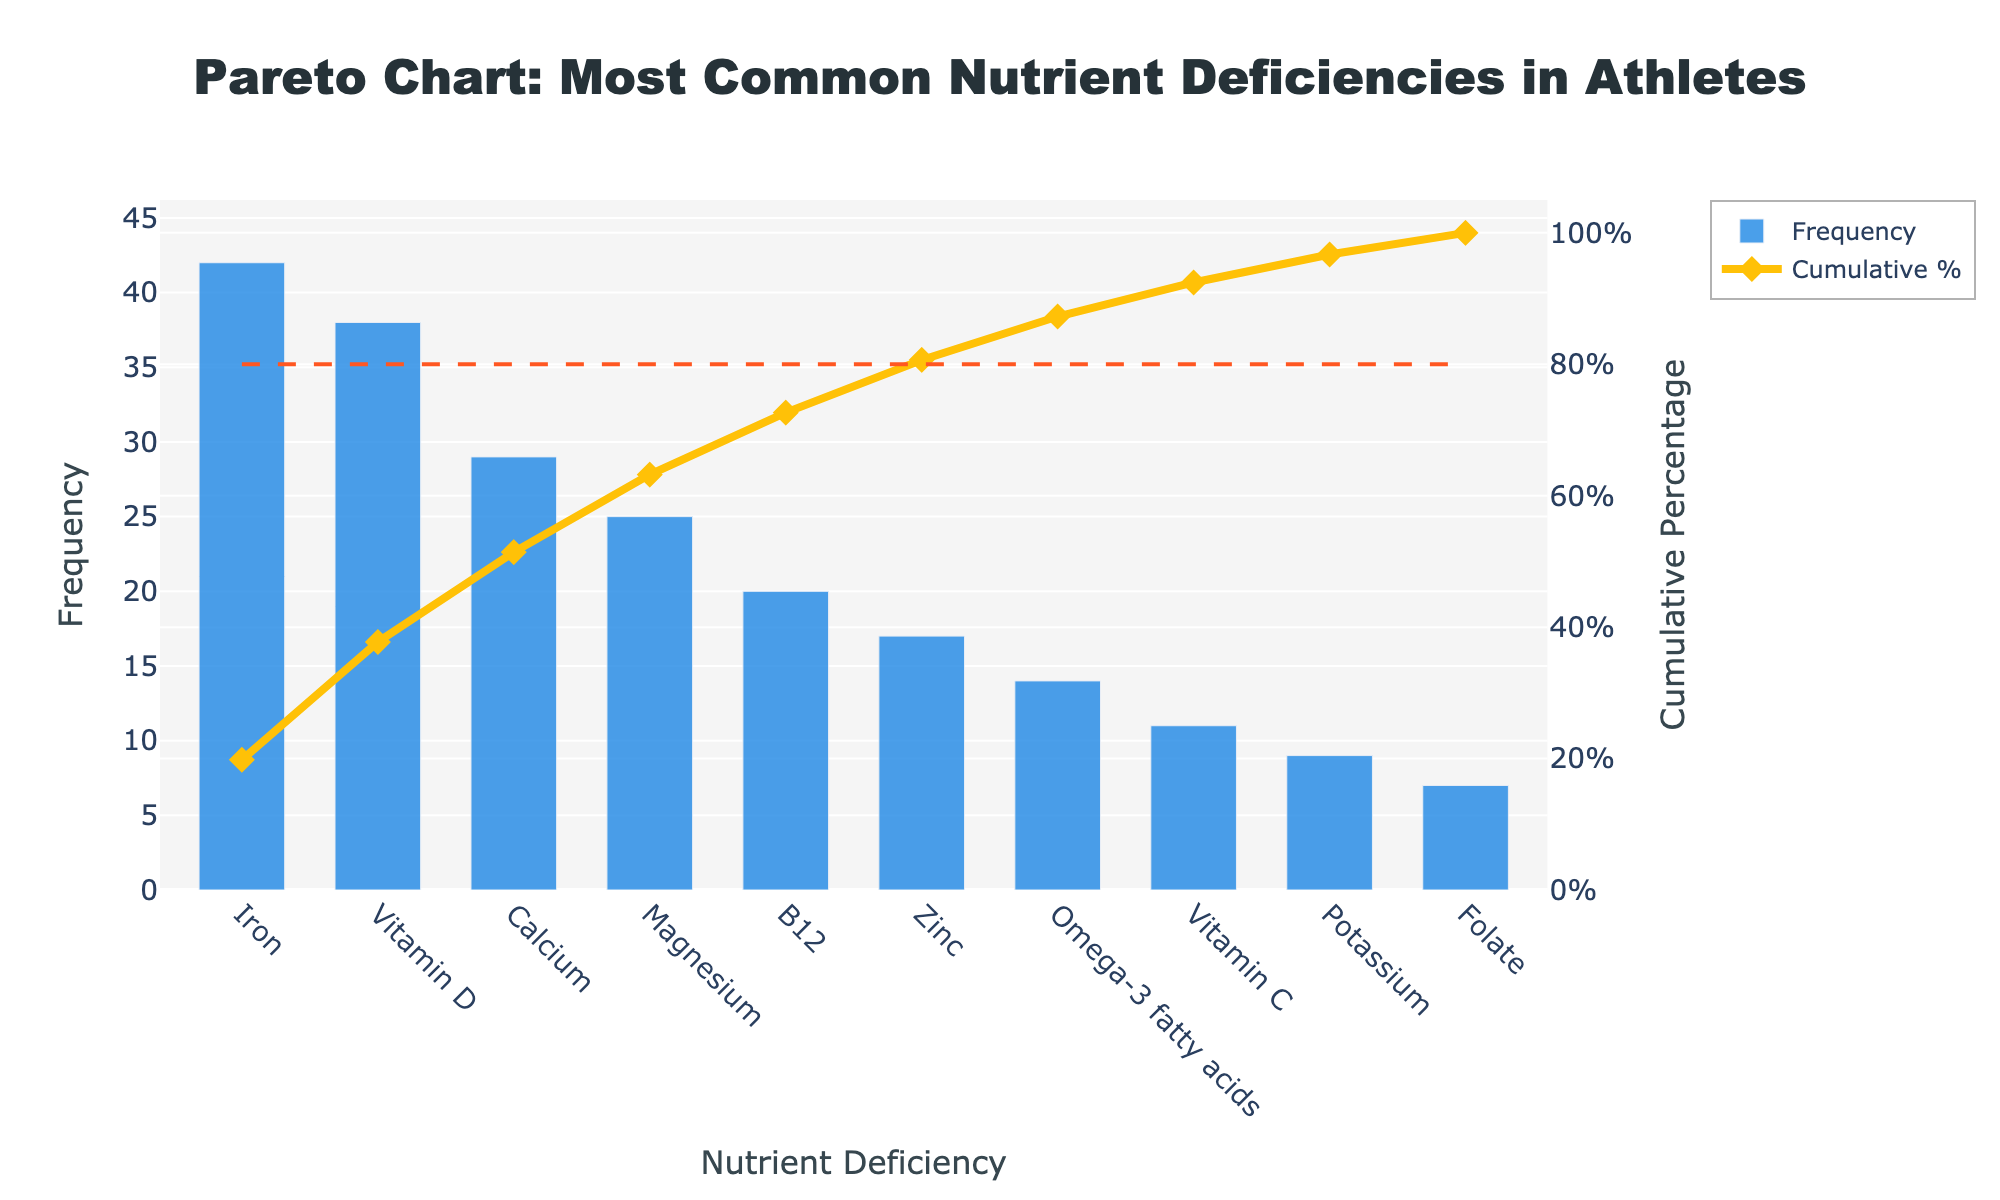What's the title of the figure? The title of a figure is typically found at the very top, often in larger or bold font. In this case, the title reads: "Pareto Chart: Most Common Nutrient Deficiencies in Athletes"
Answer: Pareto Chart: Most Common Nutrient Deficiencies in Athletes What is the most common nutrient deficiency among athletes according to the chart? The bar with the highest frequency value represents the most common deficiency. Here, the highest bar is associated with Iron, indicating it is the most common nutrient deficiency.
Answer: Iron How many nutrient deficiencies together account for 80% of the cumulative frequency? The cumulative line graph intersects the 80% horizontal line at the fourth nutrient. Thus, four nutrient deficiencies together account for 80% of all deficiencies.
Answer: Four What is the cumulative percentage for Vitamin D? Locate Vitamin D on the chart and refer to its corresponding cumulative percentage value in the line graph. This value appears to be close to 52%.
Answer: Around 52% What is the difference in frequency between Iron and Potassium deficiencies? The heights of the bars can be compared directly for Iron and Potassium. Iron has a frequency of 42 while Potassium has 9. Subtracting these gives the difference: 42 - 9.
Answer: 33 Which nutrient has the lowest frequency and what is that frequency? The shortest bar on the chart corresponds to the nutrient Folate, which has a frequency of 7.
Answer: Folate, 7 What percentage of the total deficiencies does Iron represent? The total frequency of all deficiencies must be summed, then divide Iron’s frequency (42) by this total and multiply by 100. The total is 212, so (42/212) * 100.
Answer: 19.81% Compare the frequencies of Magnesium and Zinc. Which is higher and by how much? The bar for Magnesium is taller than that for Zinc. Magnesium has a frequency of 25, and Zinc has a frequency of 17. The difference is 25 - 17.
Answer: Magnesium is higher by 8 If Iron and Vitamin D deficiencies were addressed, what percentage of nutrient deficiencies would still need to be addressed? Add the frequencies for Iron and Vitamin D (42 + 38 = 80). The total frequency is 212. Subtract this sum from the total and divide by the total, then multiply by 100 to find the remaining percentage. (212 - 80)/212 * 100.
Answer: 62.26% 